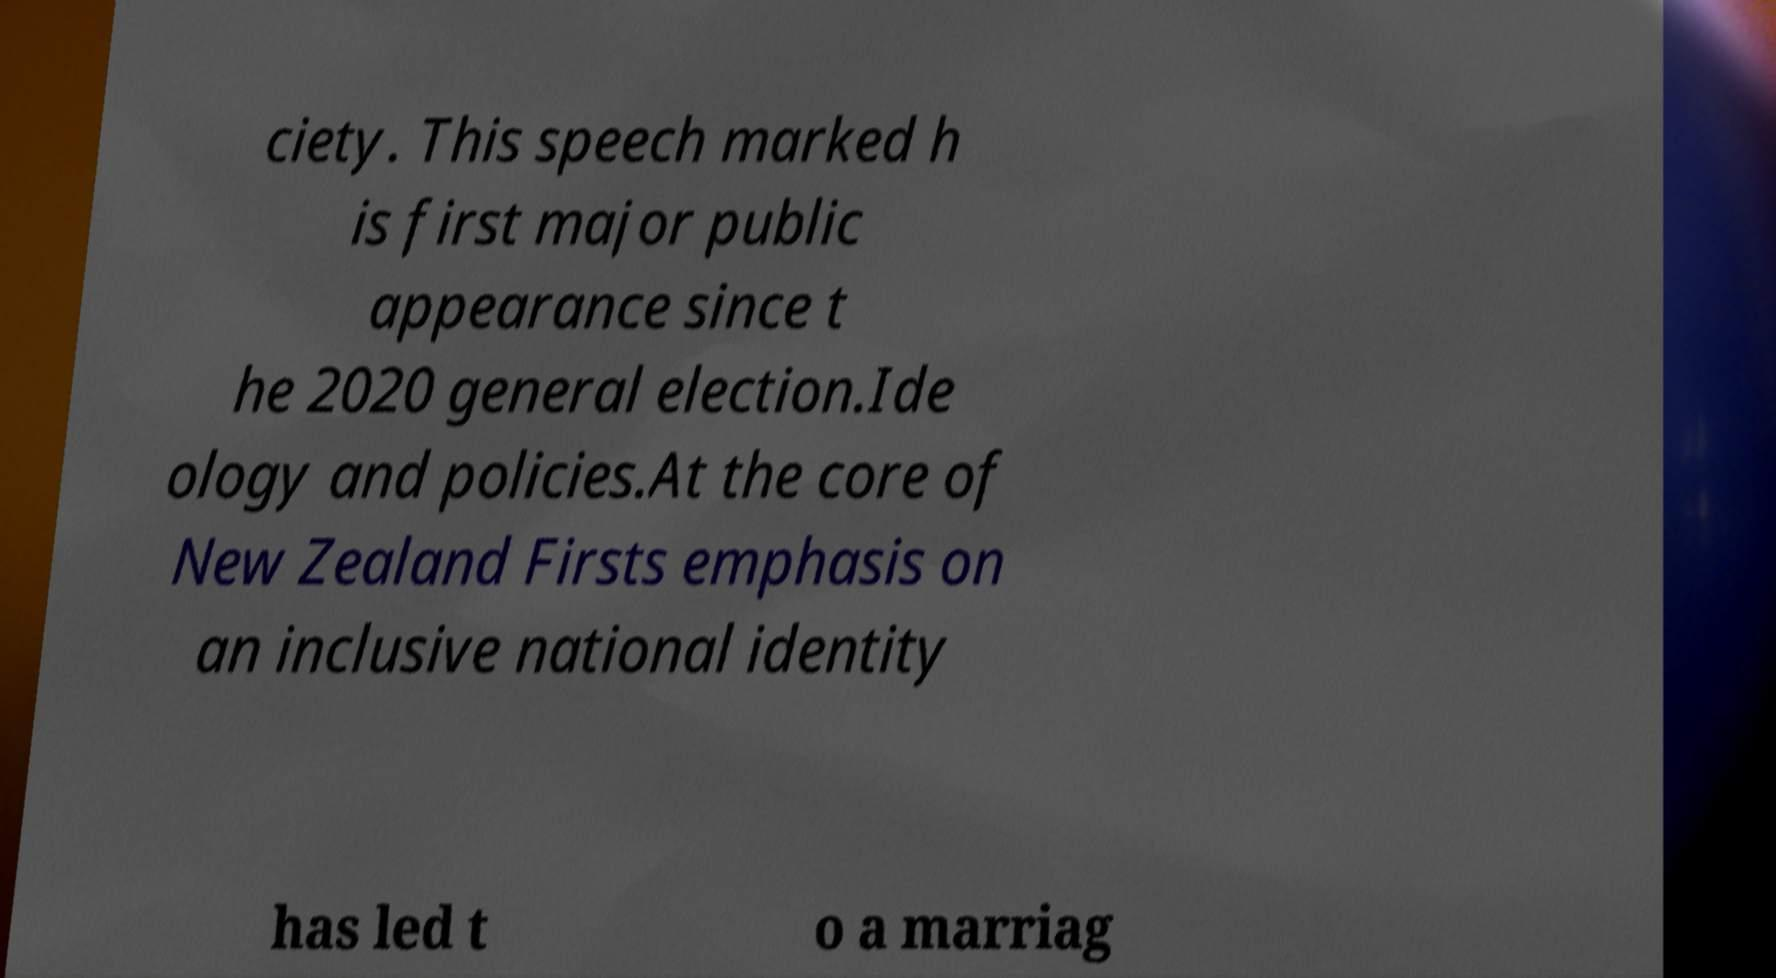For documentation purposes, I need the text within this image transcribed. Could you provide that? ciety. This speech marked h is first major public appearance since t he 2020 general election.Ide ology and policies.At the core of New Zealand Firsts emphasis on an inclusive national identity has led t o a marriag 